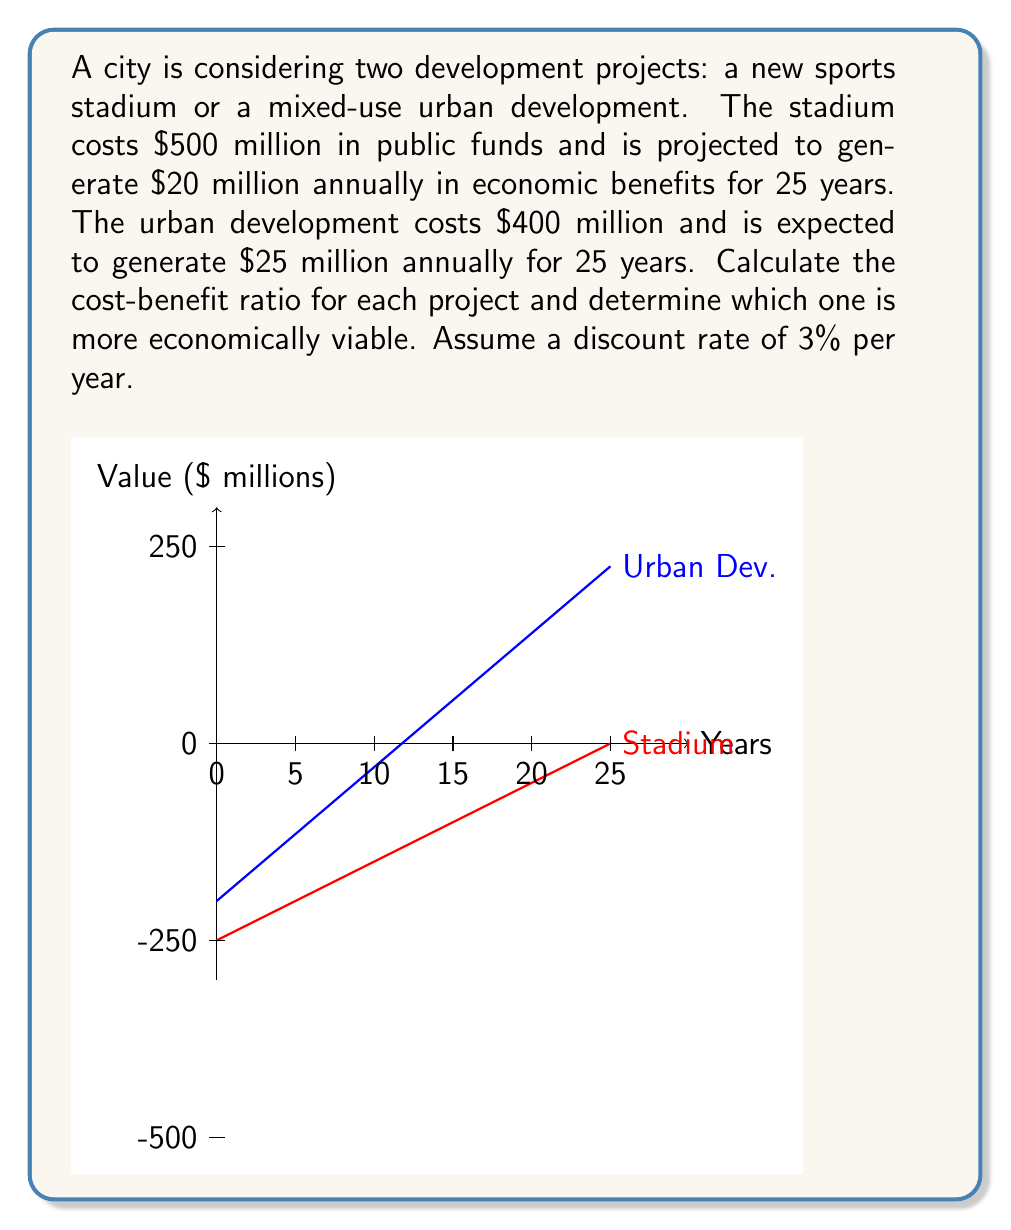Show me your answer to this math problem. To calculate the cost-benefit ratio, we need to:
1. Calculate the present value (PV) of benefits for each project
2. Divide the PV of benefits by the initial cost

Step 1: Calculate PV of benefits

We'll use the present value of an annuity formula:
$$PV = A \cdot \frac{1 - (1+r)^{-n}}{r}$$

Where:
$A$ = Annual benefit
$r$ = Discount rate
$n$ = Number of years

For the stadium:
$$PV_{stadium} = 20 \cdot \frac{1 - (1.03)^{-25}}{0.03} \approx 356.57 \text{ million}$$

For the urban development:
$$PV_{urban} = 25 \cdot \frac{1 - (1.03)^{-25}}{0.03} \approx 445.71 \text{ million}$$

Step 2: Calculate cost-benefit ratios

Stadium ratio:
$$\text{Ratio}_{stadium} = \frac{356.57}{500} \approx 0.71$$

Urban development ratio:
$$\text{Ratio}_{urban} = \frac{445.71}{400} \approx 1.11$$

The urban development project has a higher cost-benefit ratio, indicating it is more economically viable.
Answer: Stadium ratio: 0.71, Urban development ratio: 1.11. Urban development is more economically viable. 